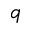Convert formula to latex. <formula><loc_0><loc_0><loc_500><loc_500>q</formula> 